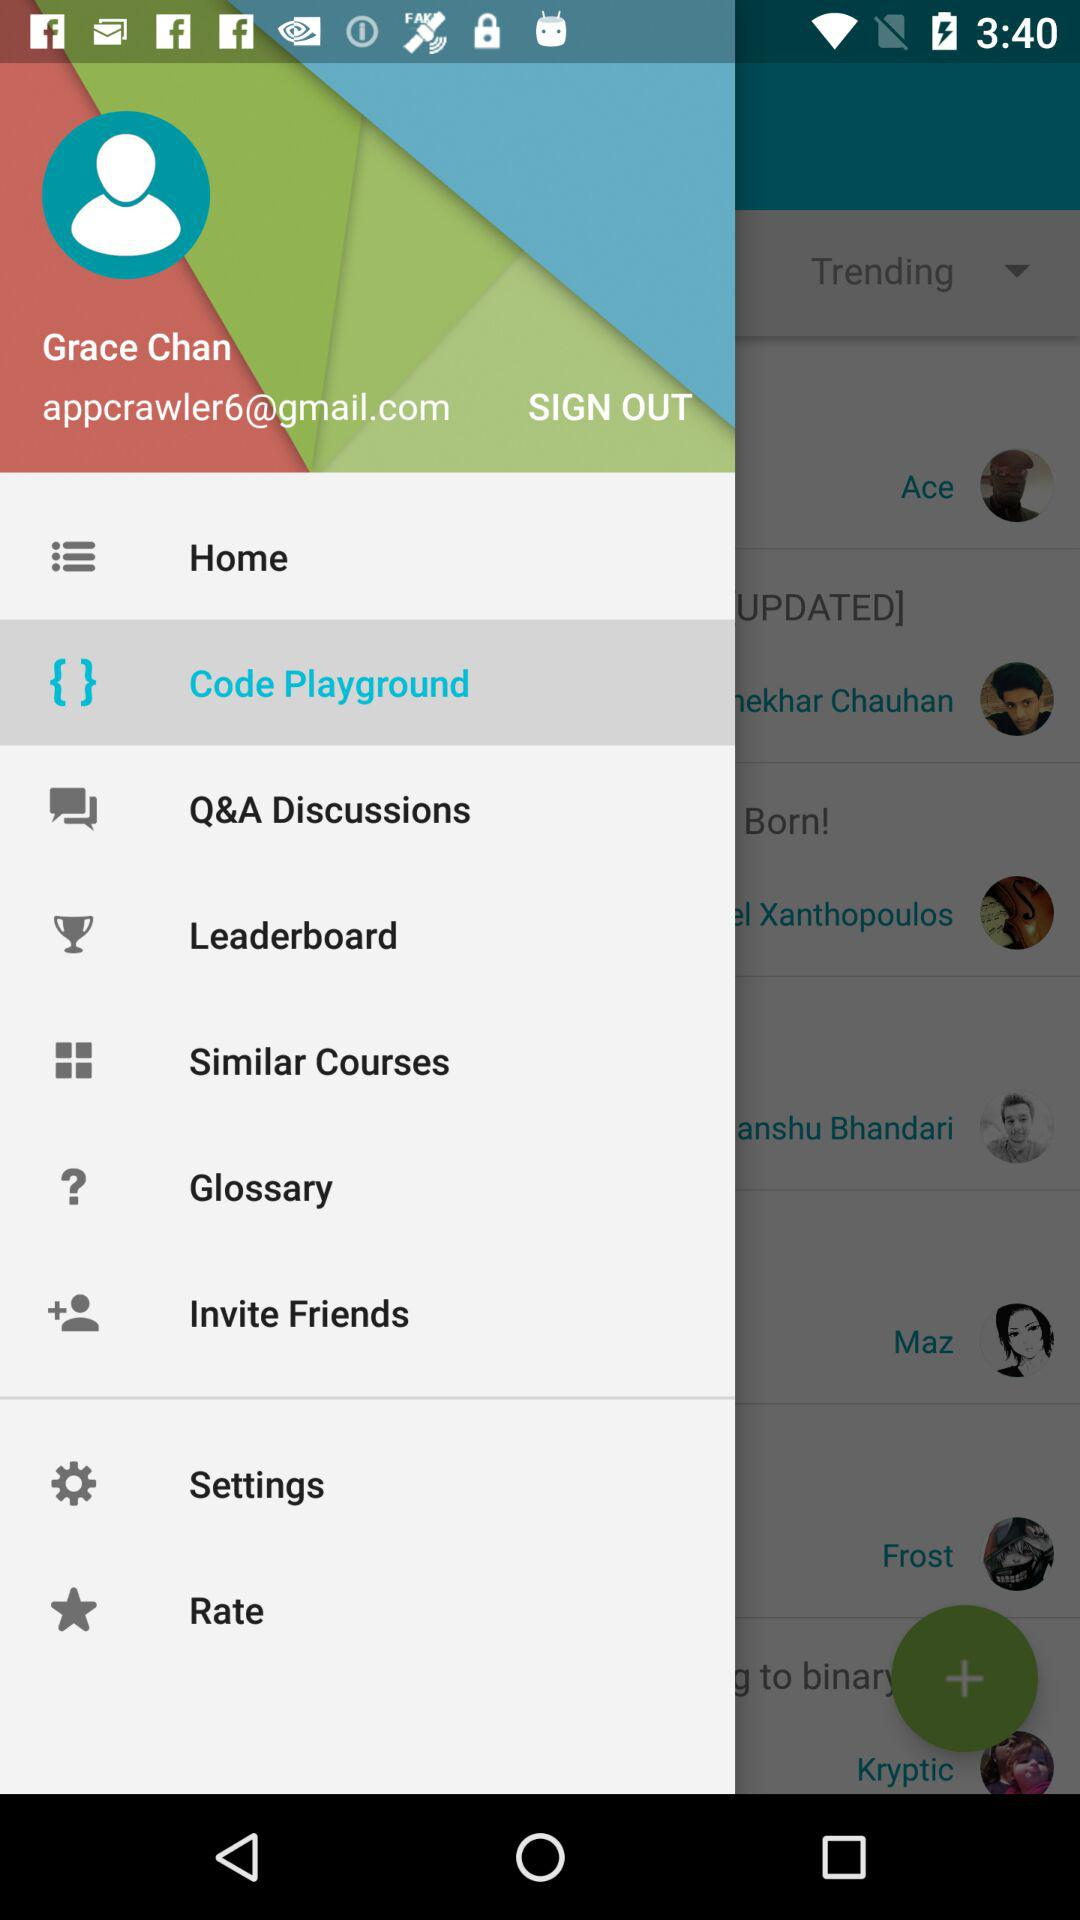Which item is selected? The selected item is "Code Playground". 